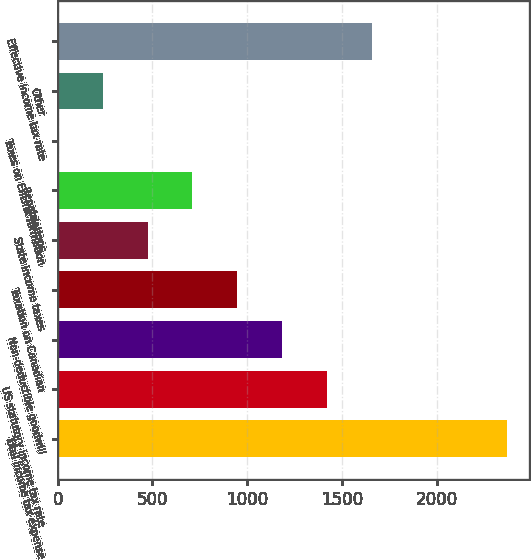Convert chart to OTSL. <chart><loc_0><loc_0><loc_500><loc_500><bar_chart><fcel>Total income tax expense<fcel>US statutory income tax rate<fcel>Non-deductible goodwill<fcel>Taxation on Canadian<fcel>State income taxes<fcel>Repatriations<fcel>Taxes on EnLink formation<fcel>Other<fcel>Effective income tax rate<nl><fcel>2368<fcel>1421.2<fcel>1184.5<fcel>947.8<fcel>474.4<fcel>711.1<fcel>1<fcel>237.7<fcel>1657.9<nl></chart> 